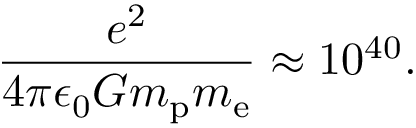<formula> <loc_0><loc_0><loc_500><loc_500>{ \frac { e ^ { 2 } } { 4 \pi \epsilon _ { 0 } G m _ { p } m _ { e } } } \approx 1 0 ^ { 4 0 } .</formula> 